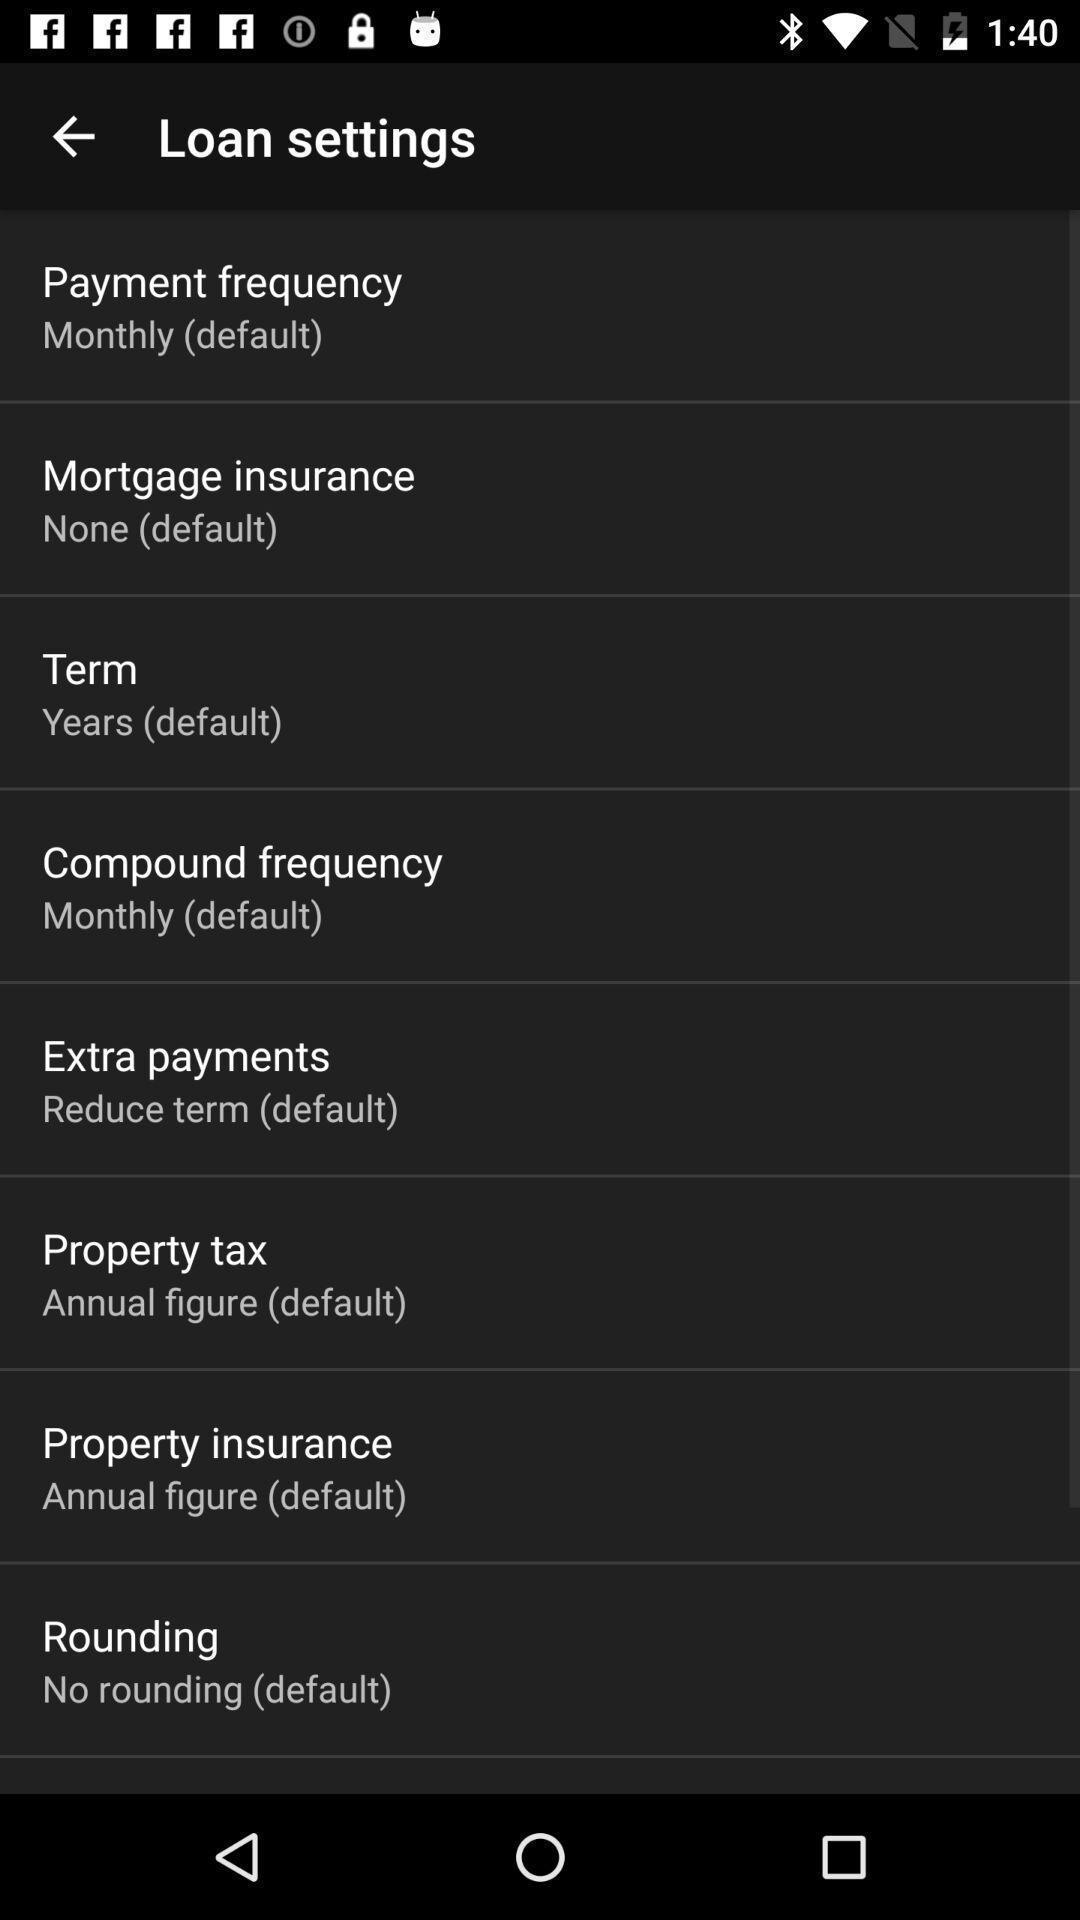Give me a summary of this screen capture. Settings page. 